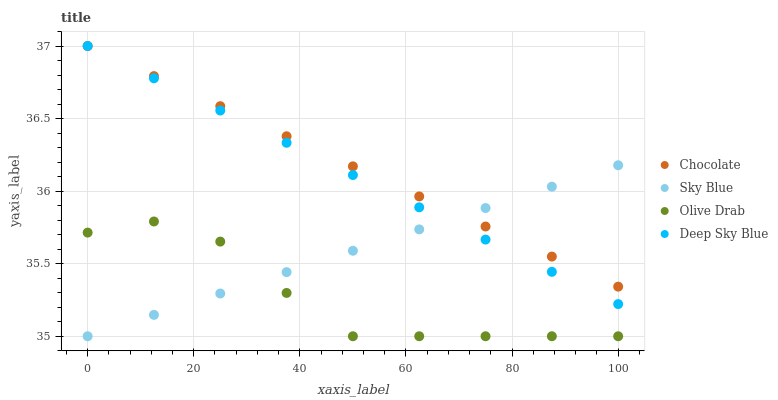Does Olive Drab have the minimum area under the curve?
Answer yes or no. Yes. Does Chocolate have the maximum area under the curve?
Answer yes or no. Yes. Does Deep Sky Blue have the minimum area under the curve?
Answer yes or no. No. Does Deep Sky Blue have the maximum area under the curve?
Answer yes or no. No. Is Sky Blue the smoothest?
Answer yes or no. Yes. Is Olive Drab the roughest?
Answer yes or no. Yes. Is Deep Sky Blue the smoothest?
Answer yes or no. No. Is Deep Sky Blue the roughest?
Answer yes or no. No. Does Sky Blue have the lowest value?
Answer yes or no. Yes. Does Deep Sky Blue have the lowest value?
Answer yes or no. No. Does Chocolate have the highest value?
Answer yes or no. Yes. Does Olive Drab have the highest value?
Answer yes or no. No. Is Olive Drab less than Chocolate?
Answer yes or no. Yes. Is Chocolate greater than Olive Drab?
Answer yes or no. Yes. Does Sky Blue intersect Olive Drab?
Answer yes or no. Yes. Is Sky Blue less than Olive Drab?
Answer yes or no. No. Is Sky Blue greater than Olive Drab?
Answer yes or no. No. Does Olive Drab intersect Chocolate?
Answer yes or no. No. 